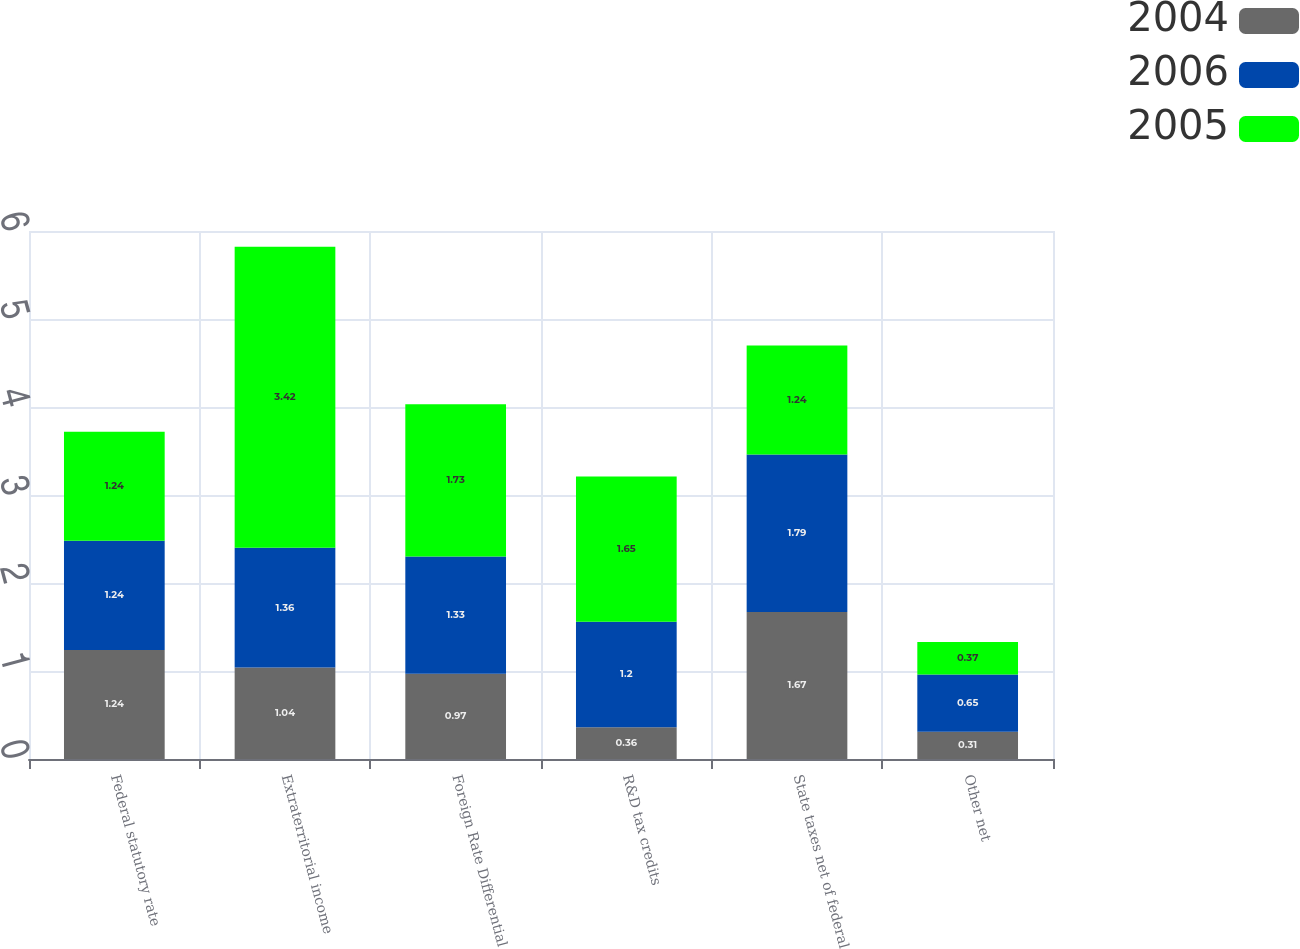<chart> <loc_0><loc_0><loc_500><loc_500><stacked_bar_chart><ecel><fcel>Federal statutory rate<fcel>Extraterritorial income<fcel>Foreign Rate Differential<fcel>R&D tax credits<fcel>State taxes net of federal<fcel>Other net<nl><fcel>2004<fcel>1.24<fcel>1.04<fcel>0.97<fcel>0.36<fcel>1.67<fcel>0.31<nl><fcel>2006<fcel>1.24<fcel>1.36<fcel>1.33<fcel>1.2<fcel>1.79<fcel>0.65<nl><fcel>2005<fcel>1.24<fcel>3.42<fcel>1.73<fcel>1.65<fcel>1.24<fcel>0.37<nl></chart> 